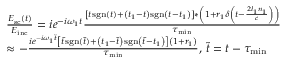Convert formula to latex. <formula><loc_0><loc_0><loc_500><loc_500>\begin{array} { r l } & { \frac { E _ { s c } ( t ) } { E _ { i n c } } = i e ^ { - i \omega _ { 1 } t } \frac { \left [ t s g n ( t ) + \left ( t _ { 1 } - t \right ) s g n \left ( t - t _ { 1 } \right ) \right ] * \left ( 1 + r _ { 1 } \delta \left ( t - \frac { 2 l _ { 1 } n _ { 1 } } { c } \right ) \right ) } { \tau _ { \min } } } \\ & { \approx - \frac { i e ^ { - i \omega _ { 1 } \tilde { t } } \left [ \tilde { t } s g n ( \tilde { t } ) + \left ( t _ { 1 } - \tilde { t } \right ) s g n \left ( \tilde { t } - t _ { 1 } \right ) \right ] \left ( 1 + r _ { 1 } \right ) } { \tau _ { \min } } , \, \tilde { t } = t - \tau _ { \min } } \end{array}</formula> 